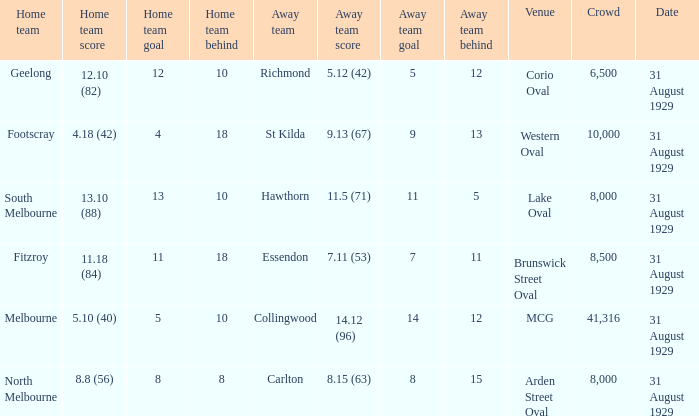What is the largest crowd when the away team is Hawthorn? 8000.0. 